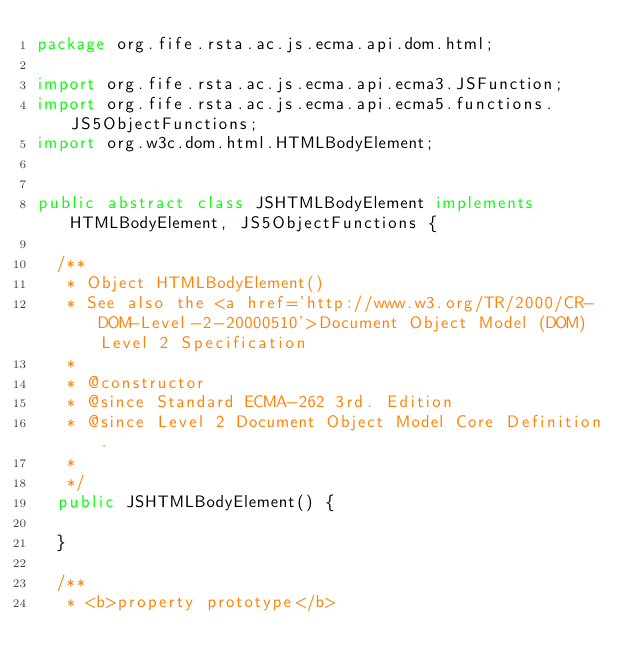Convert code to text. <code><loc_0><loc_0><loc_500><loc_500><_Java_>package org.fife.rsta.ac.js.ecma.api.dom.html;

import org.fife.rsta.ac.js.ecma.api.ecma3.JSFunction;
import org.fife.rsta.ac.js.ecma.api.ecma5.functions.JS5ObjectFunctions;
import org.w3c.dom.html.HTMLBodyElement;


public abstract class JSHTMLBodyElement implements HTMLBodyElement, JS5ObjectFunctions {

	/**
	 * Object HTMLBodyElement()
	 * See also the <a href='http://www.w3.org/TR/2000/CR-DOM-Level-2-20000510'>Document Object Model (DOM) Level 2 Specification
	 * 
	 * @constructor
	 * @since Standard ECMA-262 3rd. Edition
	 * @since Level 2 Document Object Model Core Definition.
	 * 
	 */
	public JSHTMLBodyElement() {

	}

	/**
	 * <b>property prototype</b></code> 